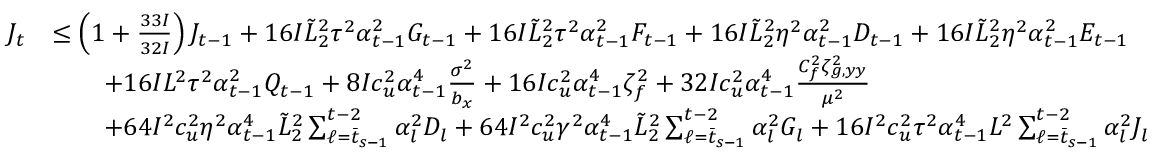<formula> <loc_0><loc_0><loc_500><loc_500>\begin{array} { r l } { J _ { t } } & { \leq \left ( 1 + \frac { 3 3 I } { 3 2 I } \right ) J _ { t - 1 } + 1 6 I \tilde { L } _ { 2 } ^ { 2 } \tau ^ { 2 } \alpha _ { t - 1 } ^ { 2 } G _ { t - 1 } + 1 6 I \tilde { L } _ { 2 } ^ { 2 } \tau ^ { 2 } \alpha _ { t - 1 } ^ { 2 } F _ { t - 1 } + 1 6 I \tilde { L } _ { 2 } ^ { 2 } \eta ^ { 2 } \alpha _ { t - 1 } ^ { 2 } D _ { t - 1 } + 1 6 I \tilde { L } _ { 2 } ^ { 2 } \eta ^ { 2 } \alpha _ { t - 1 } ^ { 2 } E _ { t - 1 } } \\ & { \quad + 1 6 I L ^ { 2 } \tau ^ { 2 } \alpha _ { t - 1 } ^ { 2 } Q _ { t - 1 } + 8 I c _ { u } ^ { 2 } \alpha _ { t - 1 } ^ { 4 } \frac { \sigma ^ { 2 } } { b _ { x } } + 1 6 I c _ { u } ^ { 2 } \alpha _ { t - 1 } ^ { 4 } \zeta _ { f } ^ { 2 } + 3 2 I c _ { u } ^ { 2 } \alpha _ { t - 1 } ^ { 4 } \frac { C _ { f } ^ { 2 } \zeta _ { g , y y } ^ { 2 } } { \mu ^ { 2 } } } \\ & { \quad + 6 4 I ^ { 2 } c _ { u } ^ { 2 } \eta ^ { 2 } \alpha _ { t - 1 } ^ { 4 } \tilde { L } _ { 2 } ^ { 2 } \sum _ { \ell = \bar { t } _ { s - 1 } } ^ { t - 2 } \alpha _ { l } ^ { 2 } D _ { l } + 6 4 I ^ { 2 } c _ { u } ^ { 2 } \gamma ^ { 2 } \alpha _ { t - 1 } ^ { 4 } \tilde { L } _ { 2 } ^ { 2 } \sum _ { \ell = \bar { t } _ { s - 1 } } ^ { t - 2 } \alpha _ { l } ^ { 2 } G _ { l } + 1 6 I ^ { 2 } c _ { u } ^ { 2 } \tau ^ { 2 } \alpha _ { t - 1 } ^ { 4 } L ^ { 2 } \sum _ { \ell = \bar { t } _ { s - 1 } } ^ { t - 2 } \alpha _ { l } ^ { 2 } J _ { l } } \end{array}</formula> 